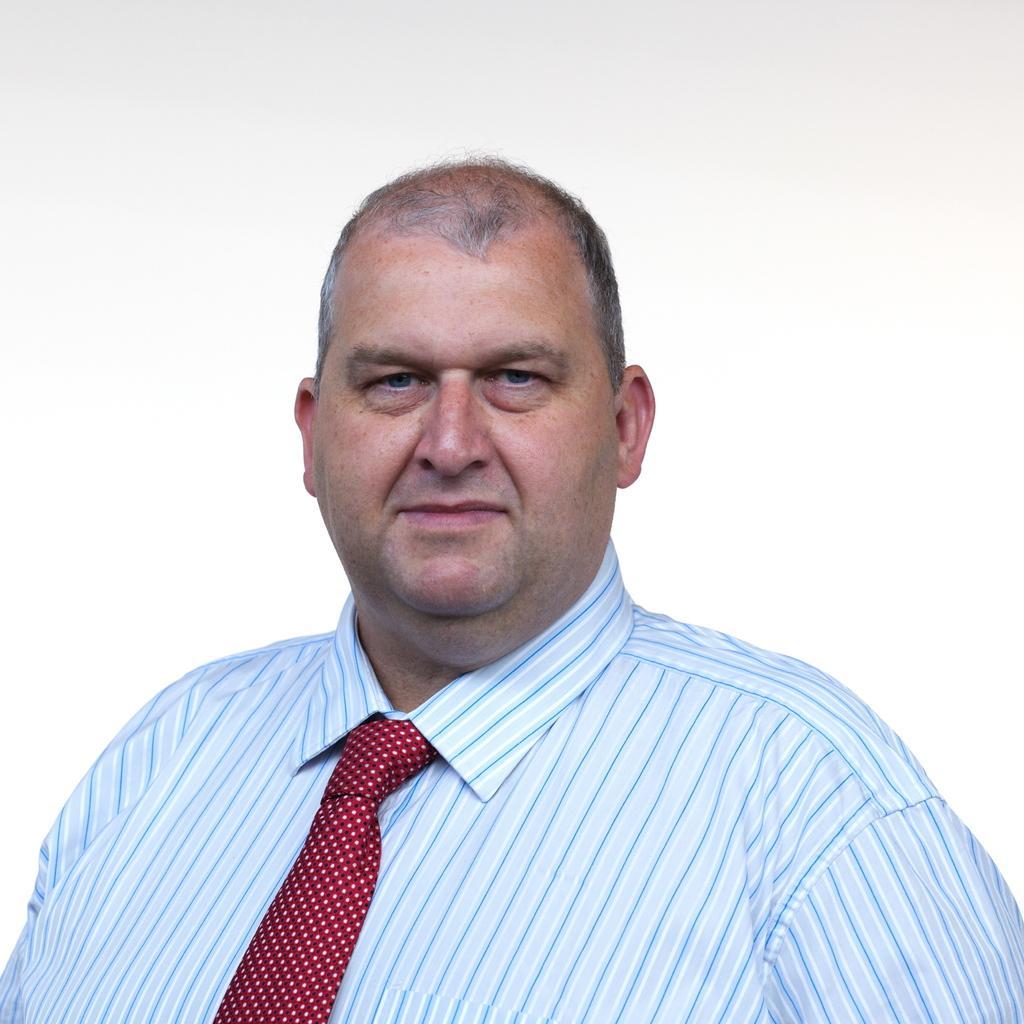Can you describe this image briefly? In the middle of the image a person is standing and smiling. Behind him we can see a wall. 